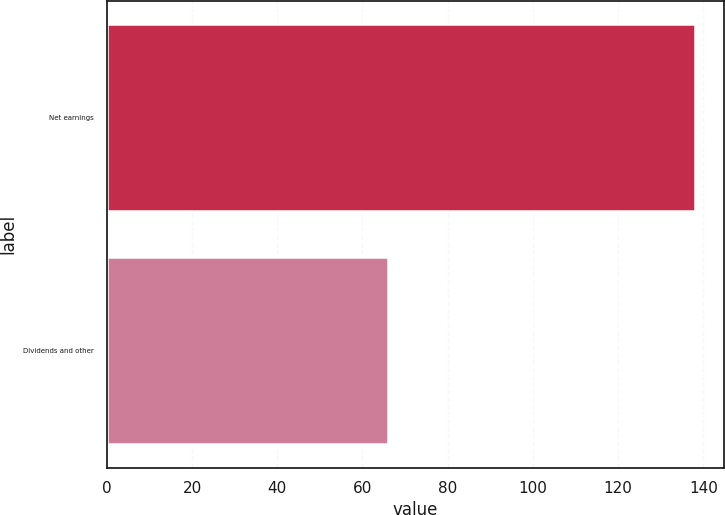Convert chart to OTSL. <chart><loc_0><loc_0><loc_500><loc_500><bar_chart><fcel>Net earnings<fcel>Dividends and other<nl><fcel>138<fcel>66<nl></chart> 